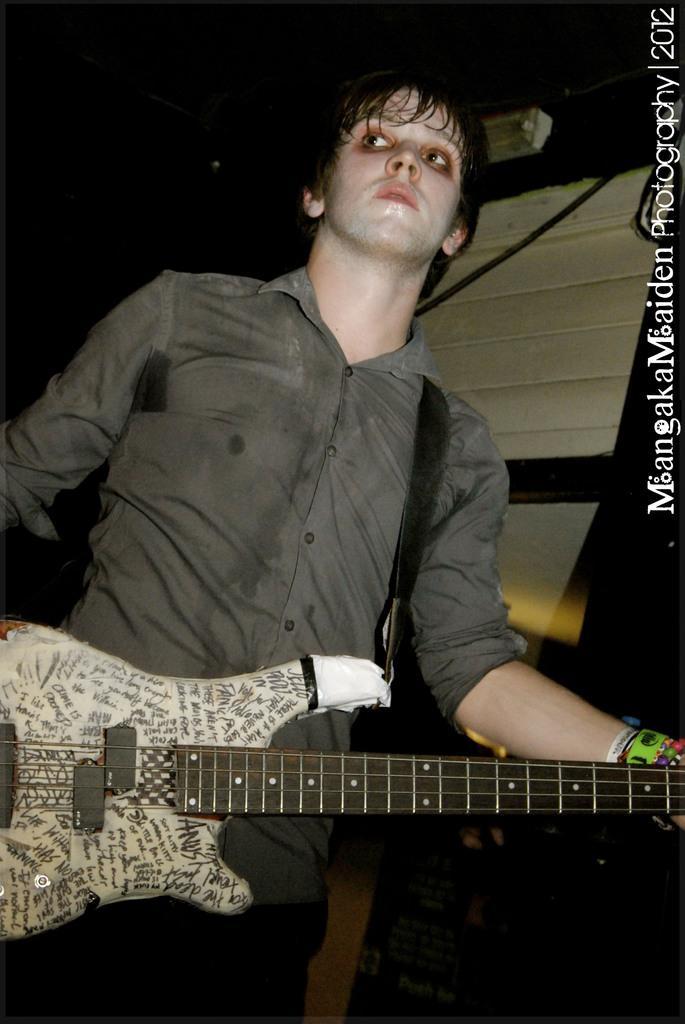Describe this image in one or two sentences. In this picture we can see a man who is holding a guitar with his hands. 